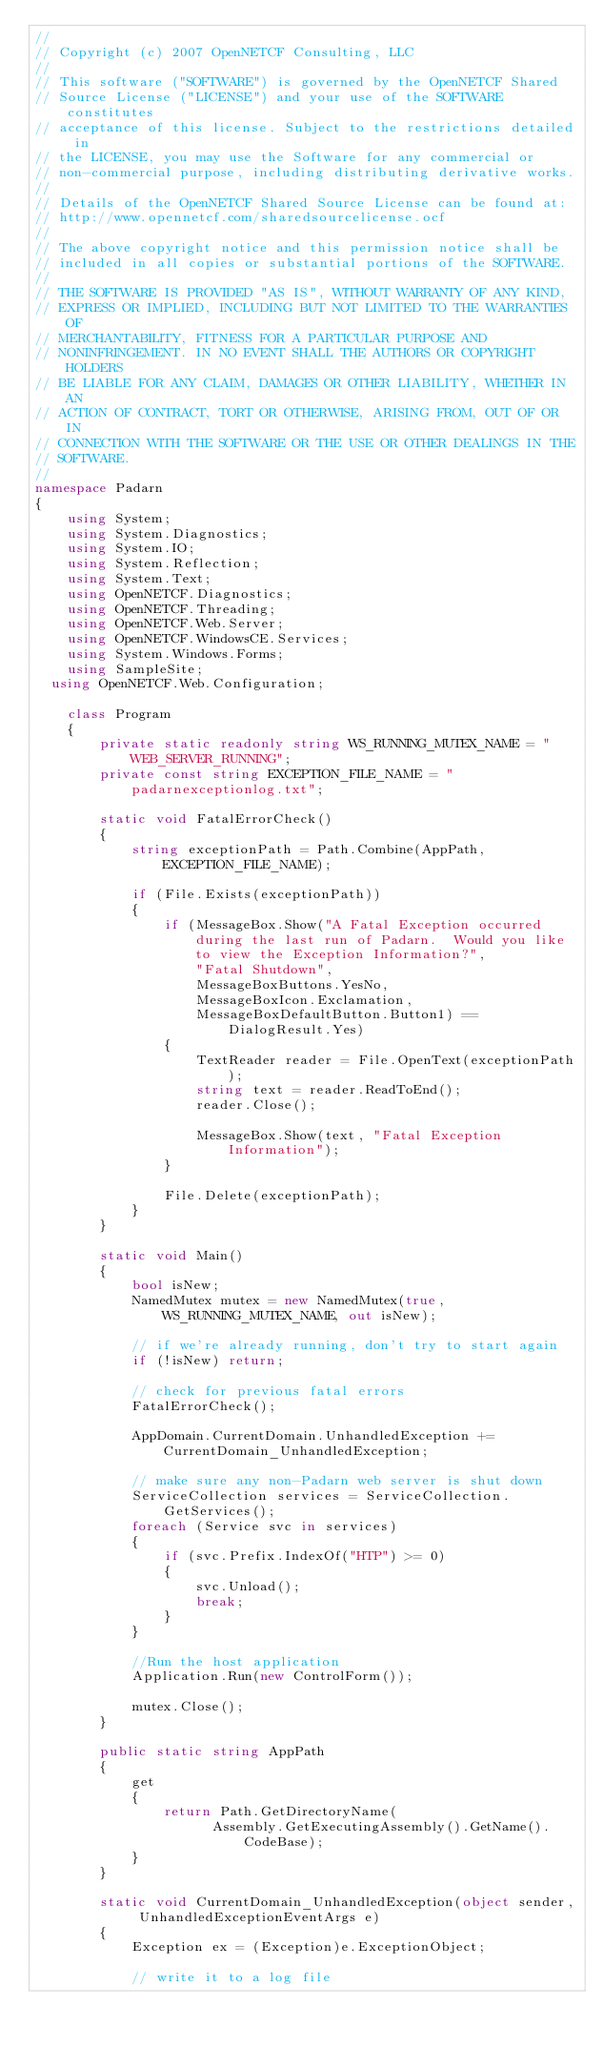<code> <loc_0><loc_0><loc_500><loc_500><_C#_>//                                                                   
// Copyright (c) 2007 OpenNETCF Consulting, LLC                        
//                                                                     
// This software ("SOFTWARE") is governed by the OpenNETCF Shared      
// Source License ("LICENSE") and your use of the SOFTWARE constitutes 
// acceptance of this license. Subject to the restrictions detailed in 
// the LICENSE, you may use the Software for any commercial or         
// non-commercial purpose, including distributing derivative works.    
//                                                                     
// Details of the OpenNETCF Shared Source License can be found at:
// http://www.opennetcf.com/sharedsourcelicense.ocf
//
// The above copyright notice and this permission notice shall be      
// included in all copies or substantial portions of the SOFTWARE.     
//                                                                     
// THE SOFTWARE IS PROVIDED "AS IS", WITHOUT WARRANTY OF ANY KIND,     
// EXPRESS OR IMPLIED, INCLUDING BUT NOT LIMITED TO THE WARRANTIES OF  
// MERCHANTABILITY, FITNESS FOR A PARTICULAR PURPOSE AND               
// NONINFRINGEMENT. IN NO EVENT SHALL THE AUTHORS OR COPYRIGHT HOLDERS 
// BE LIABLE FOR ANY CLAIM, DAMAGES OR OTHER LIABILITY, WHETHER IN AN  
// ACTION OF CONTRACT, TORT OR OTHERWISE, ARISING FROM, OUT OF OR IN   
// CONNECTION WITH THE SOFTWARE OR THE USE OR OTHER DEALINGS IN THE    
// SOFTWARE.                                                           
// 
namespace Padarn
{
    using System;
    using System.Diagnostics;
    using System.IO;
    using System.Reflection;
    using System.Text;
    using OpenNETCF.Diagnostics;
    using OpenNETCF.Threading;
    using OpenNETCF.Web.Server;
    using OpenNETCF.WindowsCE.Services;
    using System.Windows.Forms;
    using SampleSite;
  using OpenNETCF.Web.Configuration;

    class Program
    {
        private static readonly string WS_RUNNING_MUTEX_NAME = "WEB_SERVER_RUNNING";
        private const string EXCEPTION_FILE_NAME = "padarnexceptionlog.txt";

        static void FatalErrorCheck()
        {
            string exceptionPath = Path.Combine(AppPath, EXCEPTION_FILE_NAME);

            if (File.Exists(exceptionPath))
            {
                if (MessageBox.Show("A Fatal Exception occurred during the last run of Padarn.  Would you like to view the Exception Information?",
                    "Fatal Shutdown",
                    MessageBoxButtons.YesNo,
                    MessageBoxIcon.Exclamation,
                    MessageBoxDefaultButton.Button1) == DialogResult.Yes)
                {
                    TextReader reader = File.OpenText(exceptionPath);
                    string text = reader.ReadToEnd();
                    reader.Close();

                    MessageBox.Show(text, "Fatal Exception Information");
                }

                File.Delete(exceptionPath);
            }
        }

        static void Main()
        {
            bool isNew;
            NamedMutex mutex = new NamedMutex(true, WS_RUNNING_MUTEX_NAME, out isNew);

            // if we're already running, don't try to start again
            if (!isNew) return;

            // check for previous fatal errors
            FatalErrorCheck();

            AppDomain.CurrentDomain.UnhandledException += CurrentDomain_UnhandledException;
           
            // make sure any non-Padarn web server is shut down
            ServiceCollection services = ServiceCollection.GetServices();
            foreach (Service svc in services)
            {
                if (svc.Prefix.IndexOf("HTP") >= 0)
                {
                    svc.Unload();
                    break;
                }
            }

            //Run the host application
            Application.Run(new ControlForm());

            mutex.Close();
        }

        public static string AppPath
        {
            get
            {
                return Path.GetDirectoryName(
                      Assembly.GetExecutingAssembly().GetName().CodeBase);
            }
        }

        static void CurrentDomain_UnhandledException(object sender, UnhandledExceptionEventArgs e)
        {
            Exception ex = (Exception)e.ExceptionObject;

            // write it to a log file</code> 